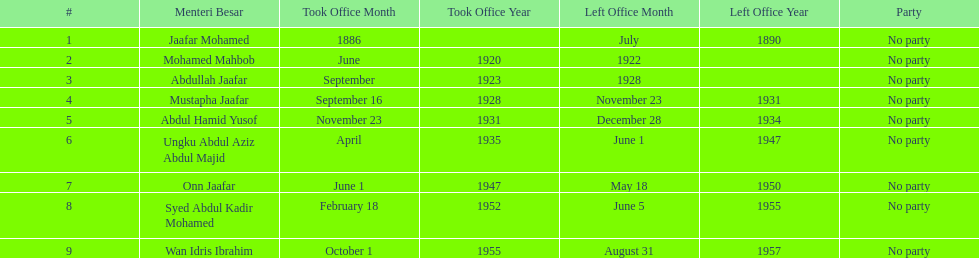What is the number of menteri besar that served 4 or more years? 3. 